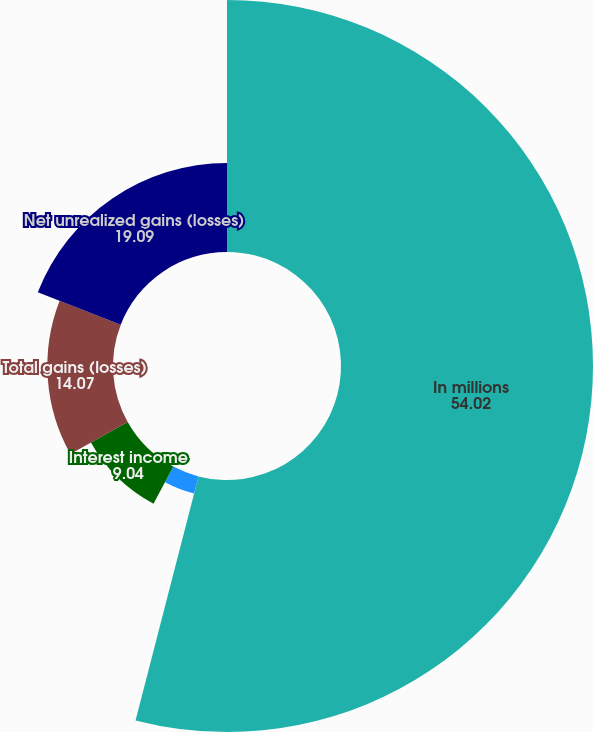Convert chart to OTSL. <chart><loc_0><loc_0><loc_500><loc_500><pie_chart><fcel>In millions<fcel>Gains (losses) on derivatives<fcel>Interest income<fcel>Total gains (losses)<fcel>Net unrealized gains (losses)<nl><fcel>54.02%<fcel>3.78%<fcel>9.04%<fcel>14.07%<fcel>19.09%<nl></chart> 